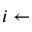<formula> <loc_0><loc_0><loc_500><loc_500>i \gets</formula> 